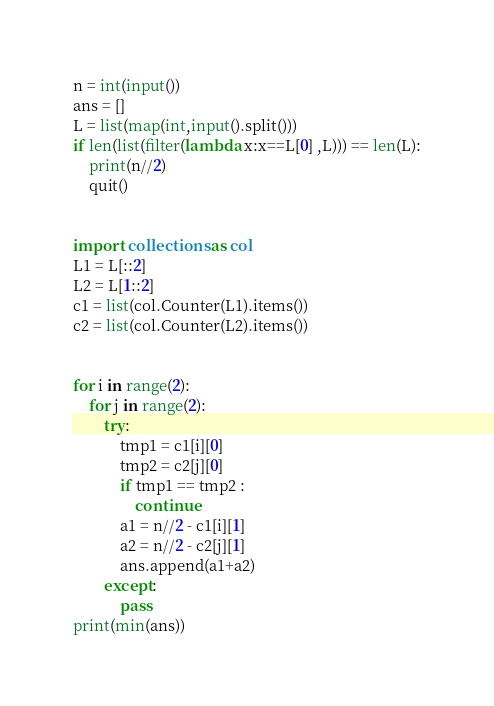Convert code to text. <code><loc_0><loc_0><loc_500><loc_500><_Python_>n = int(input())
ans = []
L = list(map(int,input().split()))
if len(list(filter(lambda x:x==L[0] ,L))) == len(L):
    print(n//2)
    quit()


import collections as col
L1 = L[::2]
L2 = L[1::2]
c1 = list(col.Counter(L1).items())
c2 = list(col.Counter(L2).items())


for i in range(2):
    for j in range(2):
        try:
            tmp1 = c1[i][0]
            tmp2 = c2[j][0]
            if tmp1 == tmp2 :
                continue
            a1 = n//2 - c1[i][1]
            a2 = n//2 - c2[j][1]
            ans.append(a1+a2)
        except:
            pass
print(min(ans))
</code> 